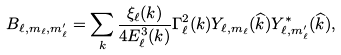<formula> <loc_0><loc_0><loc_500><loc_500>B _ { \ell , m _ { \ell } , m _ { \ell } ^ { \prime } } = \sum _ { k } \frac { \xi _ { \ell } ( k ) } { 4 E _ { \ell } ^ { 3 } ( k ) } \Gamma _ { \ell } ^ { 2 } ( k ) Y _ { \ell , m _ { \ell } } ( \widehat { k } ) Y _ { \ell , m _ { \ell } ^ { \prime } } ^ { * } ( \widehat { k } ) ,</formula> 